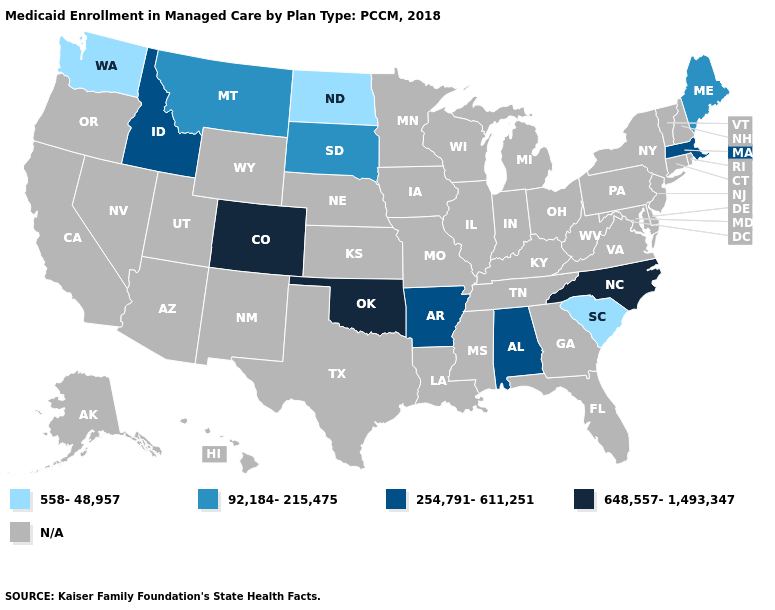Which states have the lowest value in the USA?
Give a very brief answer. North Dakota, South Carolina, Washington. Which states have the lowest value in the West?
Give a very brief answer. Washington. Does North Dakota have the lowest value in the MidWest?
Give a very brief answer. Yes. What is the value of Alabama?
Keep it brief. 254,791-611,251. Which states have the lowest value in the Northeast?
Quick response, please. Maine. Name the states that have a value in the range N/A?
Short answer required. Alaska, Arizona, California, Connecticut, Delaware, Florida, Georgia, Hawaii, Illinois, Indiana, Iowa, Kansas, Kentucky, Louisiana, Maryland, Michigan, Minnesota, Mississippi, Missouri, Nebraska, Nevada, New Hampshire, New Jersey, New Mexico, New York, Ohio, Oregon, Pennsylvania, Rhode Island, Tennessee, Texas, Utah, Vermont, Virginia, West Virginia, Wisconsin, Wyoming. Name the states that have a value in the range 254,791-611,251?
Answer briefly. Alabama, Arkansas, Idaho, Massachusetts. What is the value of New Jersey?
Concise answer only. N/A. What is the value of Oklahoma?
Concise answer only. 648,557-1,493,347. Name the states that have a value in the range 254,791-611,251?
Concise answer only. Alabama, Arkansas, Idaho, Massachusetts. Does South Dakota have the lowest value in the USA?
Quick response, please. No. What is the lowest value in the USA?
Be succinct. 558-48,957. What is the value of Wisconsin?
Give a very brief answer. N/A. 